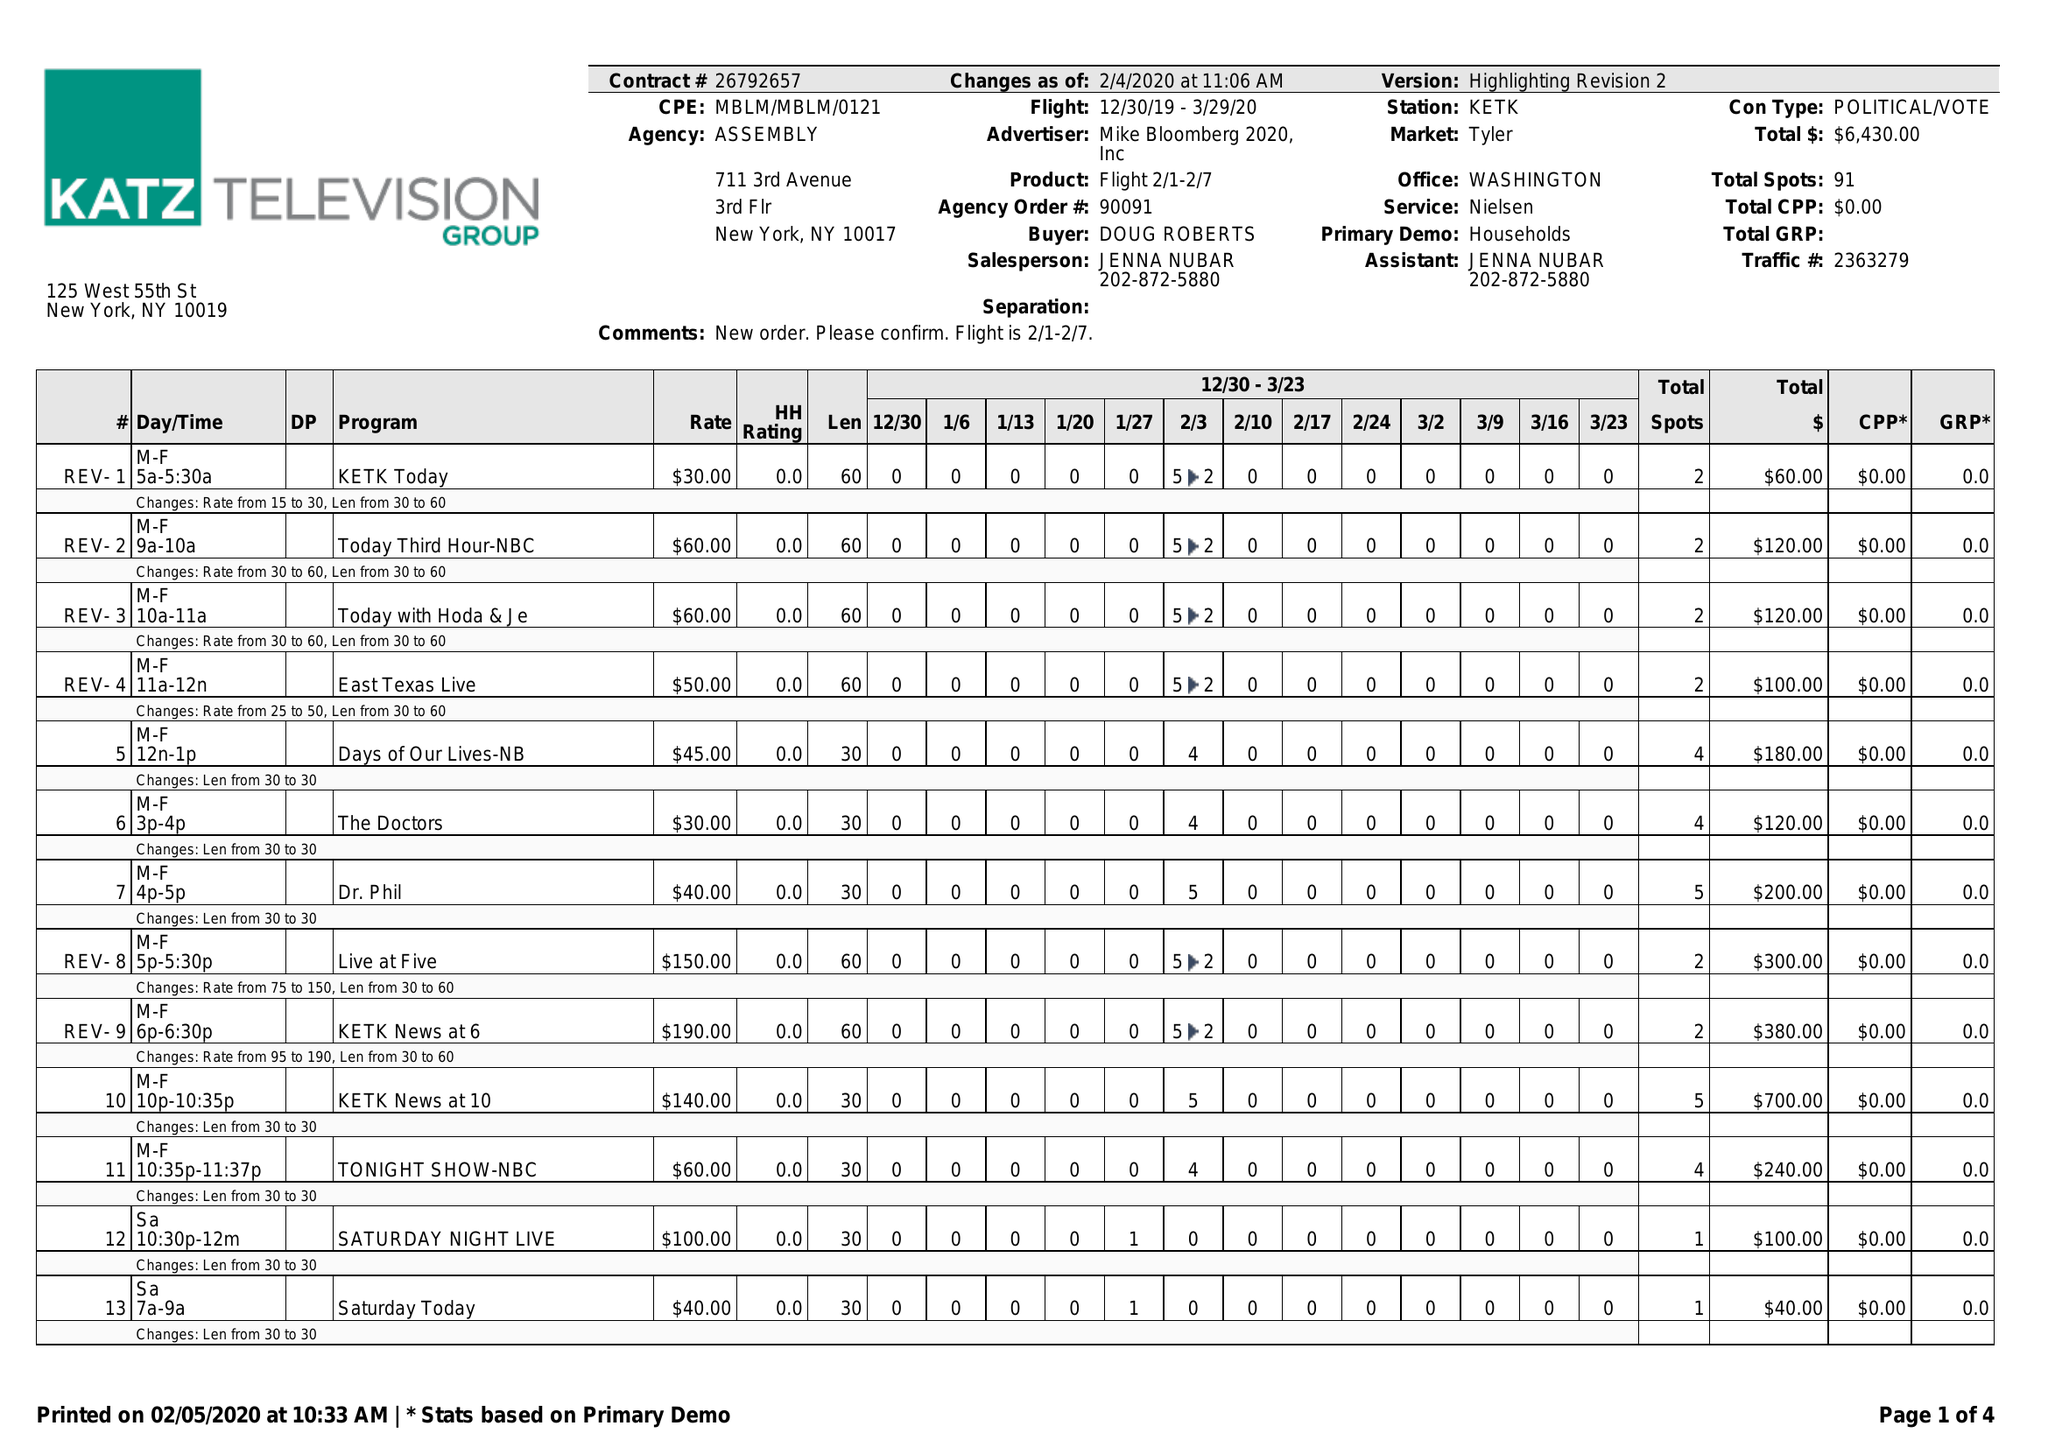What is the value for the gross_amount?
Answer the question using a single word or phrase. 6430.00 